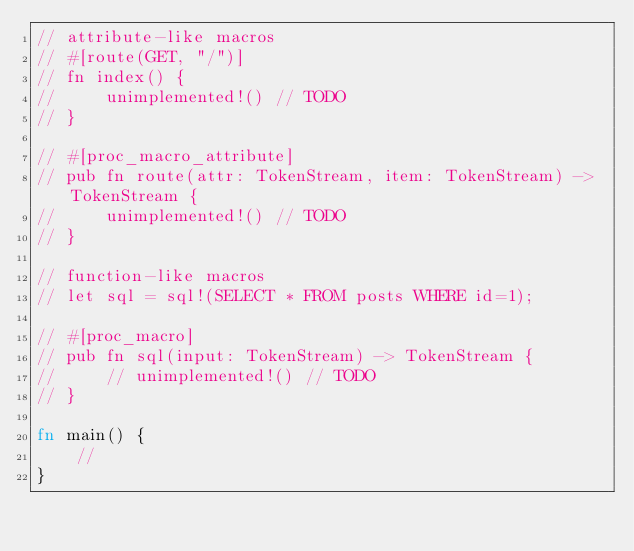<code> <loc_0><loc_0><loc_500><loc_500><_Rust_>// attribute-like macros
// #[route(GET, "/")]
// fn index() {
//     unimplemented!() // TODO
// }

// #[proc_macro_attribute]
// pub fn route(attr: TokenStream, item: TokenStream) -> TokenStream {
//     unimplemented!() // TODO
// }

// function-like macros
// let sql = sql!(SELECT * FROM posts WHERE id=1);

// #[proc_macro]
// pub fn sql(input: TokenStream) -> TokenStream {
//     // unimplemented!() // TODO
// }

fn main() {
    //
}
</code> 